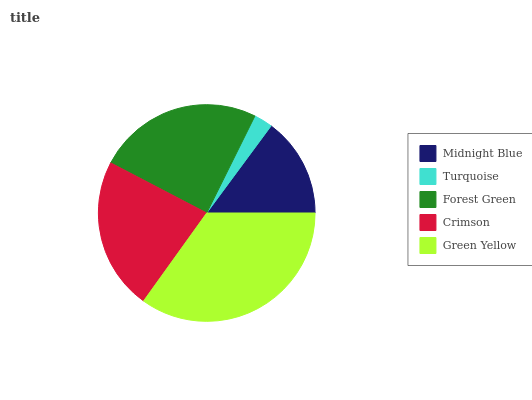Is Turquoise the minimum?
Answer yes or no. Yes. Is Green Yellow the maximum?
Answer yes or no. Yes. Is Forest Green the minimum?
Answer yes or no. No. Is Forest Green the maximum?
Answer yes or no. No. Is Forest Green greater than Turquoise?
Answer yes or no. Yes. Is Turquoise less than Forest Green?
Answer yes or no. Yes. Is Turquoise greater than Forest Green?
Answer yes or no. No. Is Forest Green less than Turquoise?
Answer yes or no. No. Is Crimson the high median?
Answer yes or no. Yes. Is Crimson the low median?
Answer yes or no. Yes. Is Forest Green the high median?
Answer yes or no. No. Is Midnight Blue the low median?
Answer yes or no. No. 